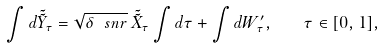Convert formula to latex. <formula><loc_0><loc_0><loc_500><loc_500>\int d \tilde { \tilde { Y } } _ { \tau } = \sqrt { \delta \, \ s n r } \, \tilde { \tilde { X } } _ { \tau } \int d \tau + \int d W ^ { \prime } _ { \tau } , \quad \tau \in [ 0 , 1 ] ,</formula> 